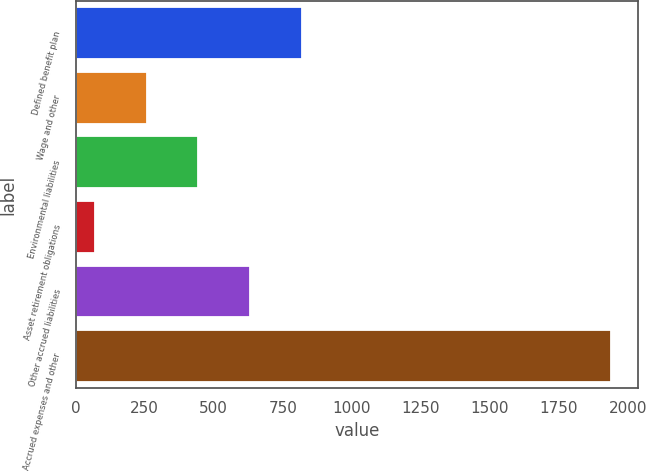Convert chart. <chart><loc_0><loc_0><loc_500><loc_500><bar_chart><fcel>Defined benefit plan<fcel>Wage and other<fcel>Environmental liabilities<fcel>Asset retirement obligations<fcel>Other accrued liabilities<fcel>Accrued expenses and other<nl><fcel>818.2<fcel>257.8<fcel>444.6<fcel>71<fcel>631.4<fcel>1939<nl></chart> 